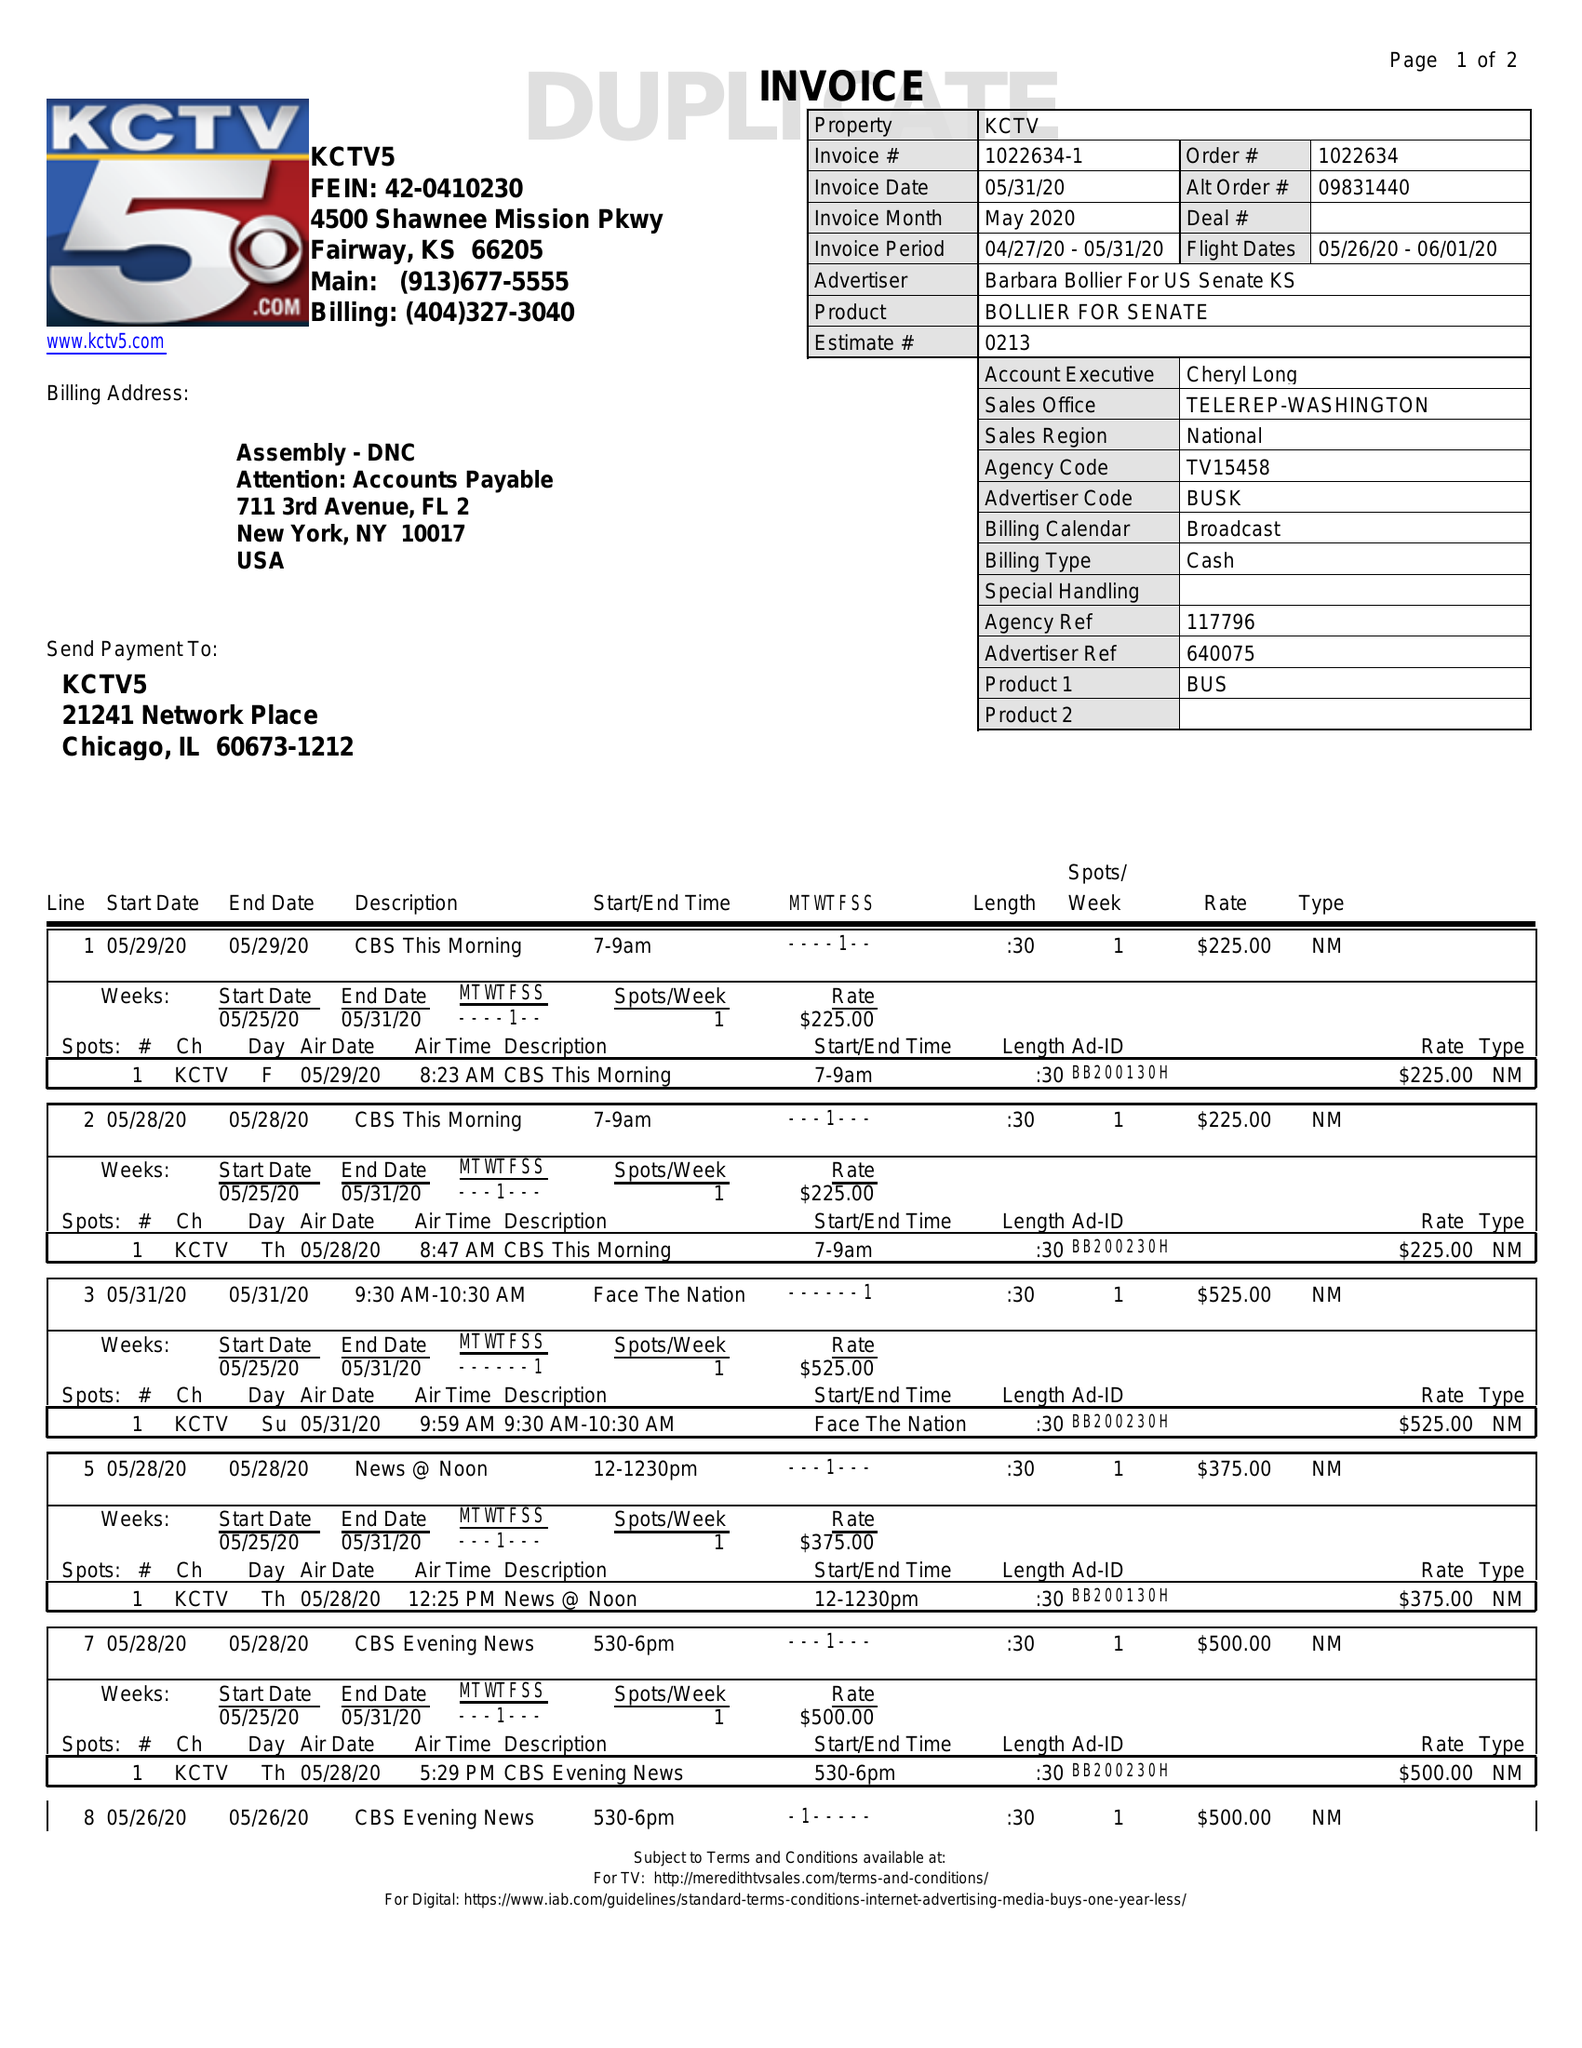What is the value for the flight_from?
Answer the question using a single word or phrase. 05/26/20 